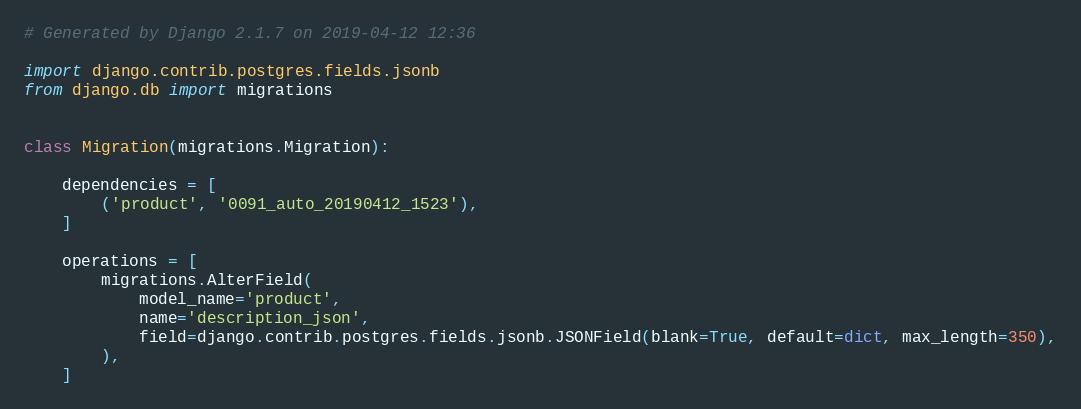Convert code to text. <code><loc_0><loc_0><loc_500><loc_500><_Python_># Generated by Django 2.1.7 on 2019-04-12 12:36

import django.contrib.postgres.fields.jsonb
from django.db import migrations


class Migration(migrations.Migration):

    dependencies = [
        ('product', '0091_auto_20190412_1523'),
    ]

    operations = [
        migrations.AlterField(
            model_name='product',
            name='description_json',
            field=django.contrib.postgres.fields.jsonb.JSONField(blank=True, default=dict, max_length=350),
        ),
    ]
</code> 